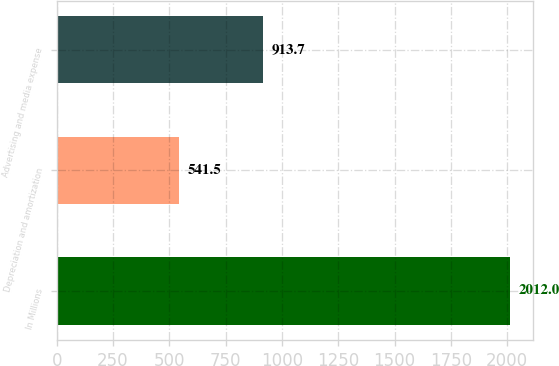Convert chart. <chart><loc_0><loc_0><loc_500><loc_500><bar_chart><fcel>In Millions<fcel>Depreciation and amortization<fcel>Advertising and media expense<nl><fcel>2012<fcel>541.5<fcel>913.7<nl></chart> 